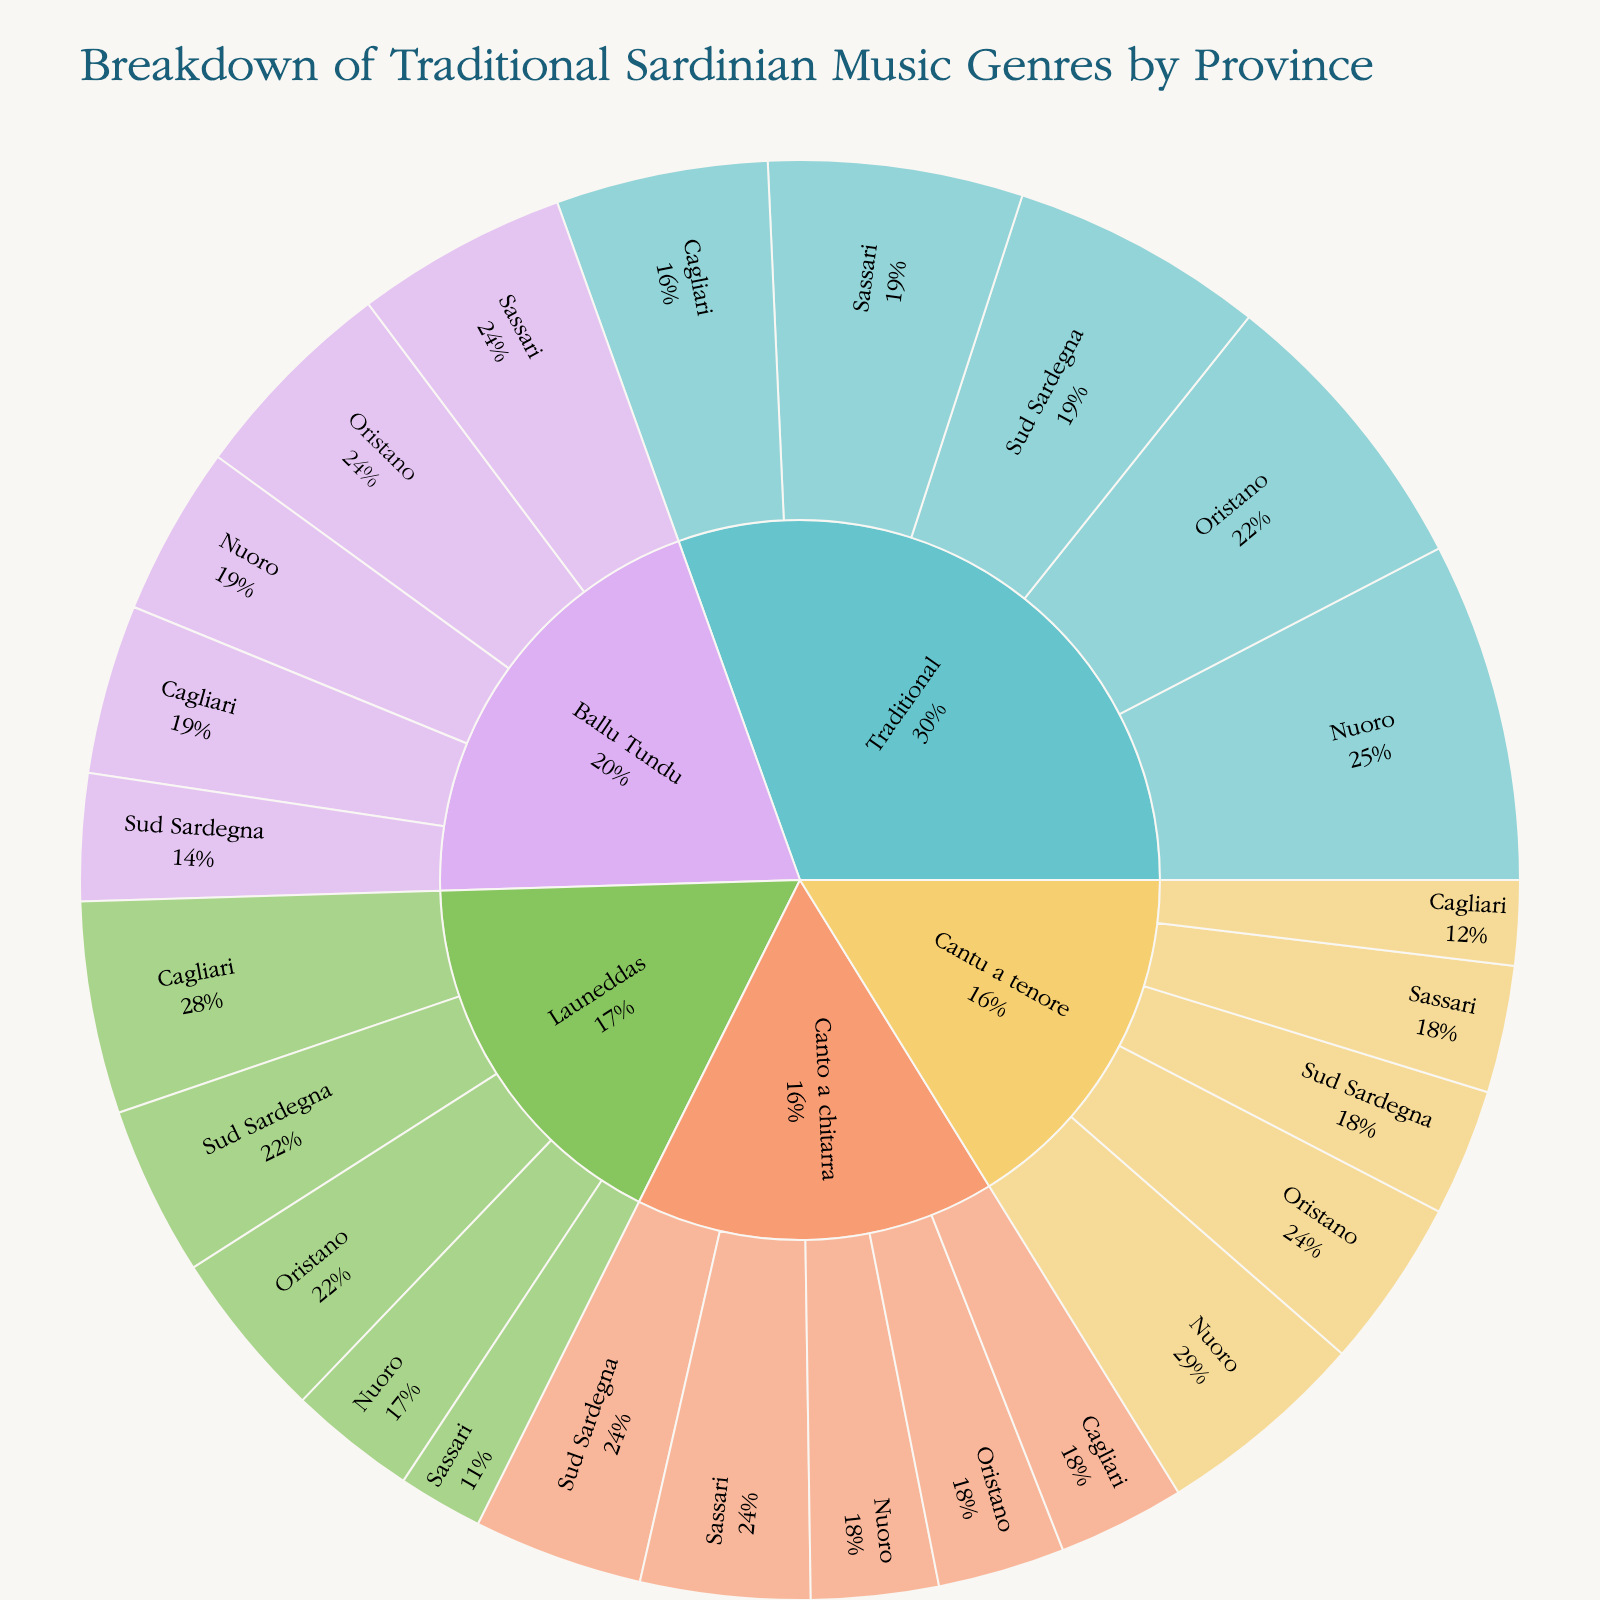What's the title of the figure? The figure's title is typically displayed at the top and provides a summary of what the figure represents. In this case, it is the "Breakdown of Traditional Sardinian Music Genres by Province".
Answer: Breakdown of Traditional Sardinian Music Genres by Province Which genre is the most popular in Nuoro? By looking at the hierarchical structure of the sunburst plot, we can find Nuoro under each genre and see their respective popularity values. For Nuoro, the "Traditional" genre has the highest popularity among all genres with a value of 40.
Answer: Traditional How does the popularity of "Cantu a tenore" in Sassari compare to its popularity in Sud Sardegna? To compare the popularity values, we check the segments corresponding to "Cantu a tenore" for Sassari and Sud Sardegna. Sassari has a popularity value of 15 while Sud Sardegna has a value of 15. Therefore, they are equal.
Answer: They are equal What is the total popularity of "Launeddas" across all provinces? We need to sum the popularity values of Launeddas across Sassari, Nuoro, Oristano, Cagliari, and Sud Sardegna. These values are 10, 15, 20, 25, and 20 respectively. Summing them up results in: 10 + 15 + 20 + 25 + 20 = 90.
Answer: 90 Which province has the highest combined popularity for all music genres? To find this, sum the popularity values for all genres in each province. Sassari: 30+15+10+20+25=100, Nuoro: 40+25+15+15+20=115, Oristano: 35+20+20+15+25=115, Cagliari: 25+10+25+15+20=95, Sud Sardegna: 30+15+20+20+15=100. Nuoro and Oristano both have the highest combined popularity of 115.
Answer: Nuoro and Oristano What fraction of the total popularity does "Ballu Tundu" in Oristano represent? Find the total popularity for all entries first. Sum: 30+40+35+25+30 + 15+25+20+10+15 + 10+15+20+25+20 + 20+15+15+15+20 + 25+20+25+20+15 = 470. "Ballu Tundu" in Oristano has a popularity of 25, so the fraction is 25/470.
Answer: 25/470 Which genre experiences the smallest difference in popularity between Sassari and Cagliari? Compare the popularity differences for each genre between Sassari and Cagliari. Traditional: 30-25=5, Cantu a tenore: 15-10=5, Launeddas: 10-25=15, Canto a chitarra: 20-15=5, Ballu Tundu: 25-20=5. The smallest difference is 5, found in multiple genres.
Answer: Traditional, Cantu a tenore, Canto a chitarra, Ballu Tundu (each 5) What's the average popularity of "Canto a chitarra" across all provinces? Sum the popularity values for "Canto a chitarra" across all provinces which are 20, 15, 15, 15, and 20, then divide by the number of provinces (5): (20+15+15+15+20)/5 = 85/5 = 17.
Answer: 17 What is the least popular genre in Cagliari? By looking at the popularity values for each genre in Cagliari, we can find that "Cantu a tenore" has the lowest value of 10.
Answer: Cantu a tenore 